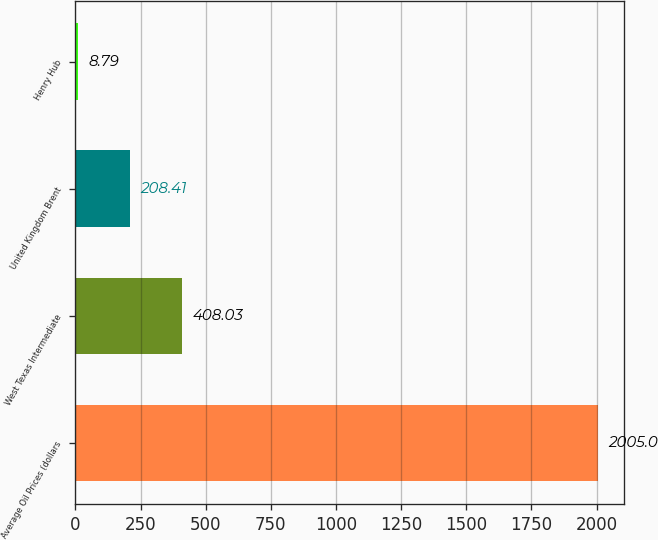Convert chart. <chart><loc_0><loc_0><loc_500><loc_500><bar_chart><fcel>Average Oil Prices (dollars<fcel>West Texas Intermediate<fcel>United Kingdom Brent<fcel>Henry Hub<nl><fcel>2005<fcel>408.03<fcel>208.41<fcel>8.79<nl></chart> 